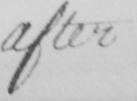Can you read and transcribe this handwriting? after 